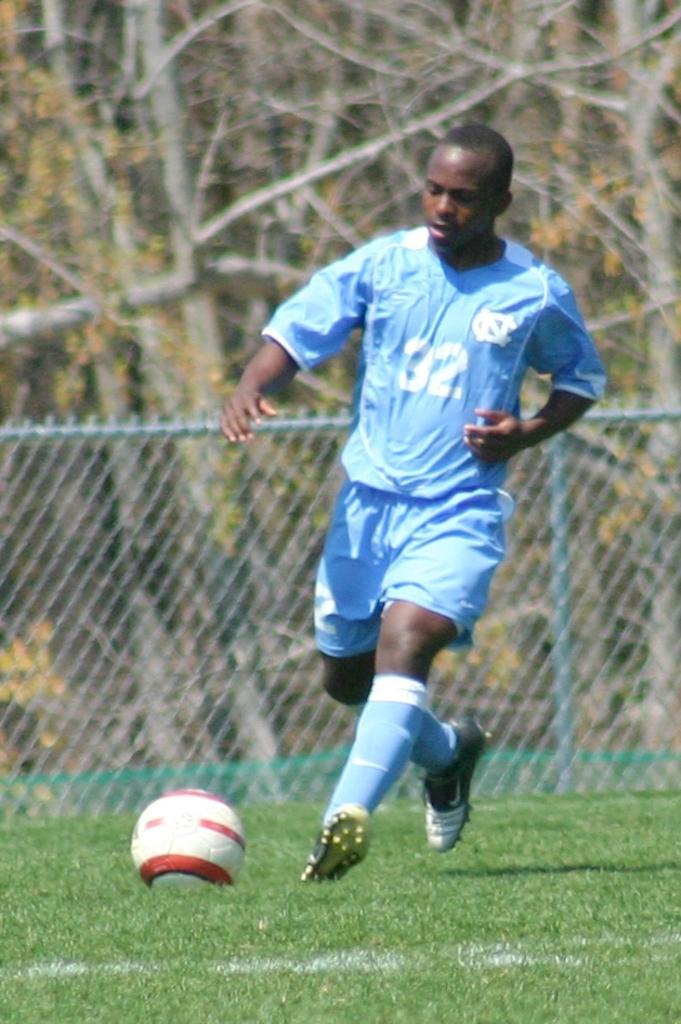Could you give a brief overview of what you see in this image? At the bottom I can see the grass. Here a man wearing a t-shirt, short and playing football. In the background there is a railing and trees. 